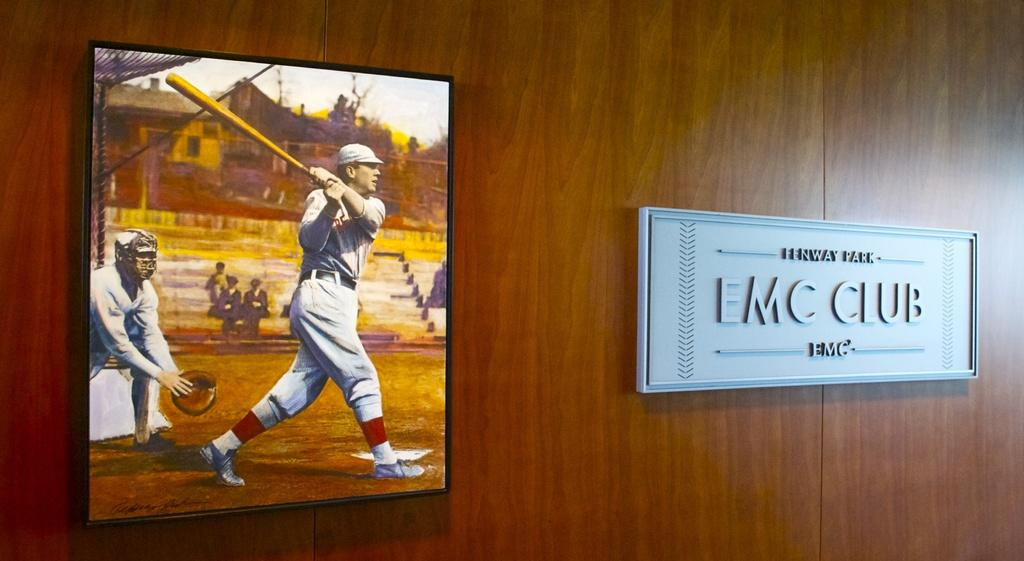<image>
Write a terse but informative summary of the picture. An EMC club plaque on a wall next to a baseball picture. 